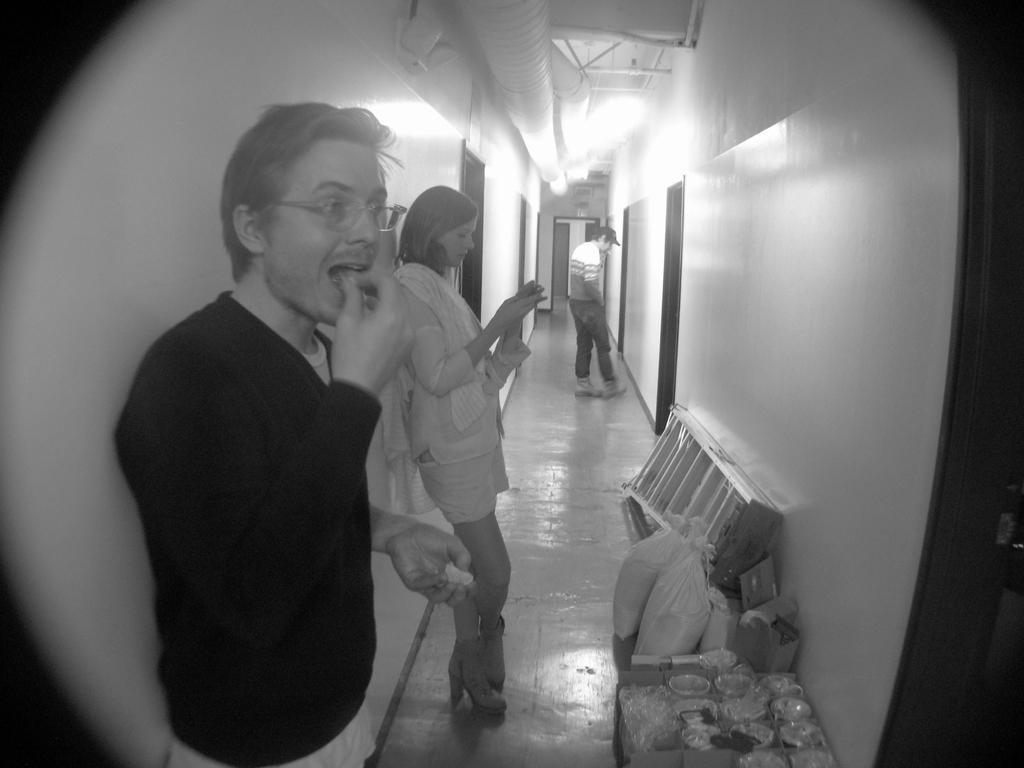In one or two sentences, can you explain what this image depicts? In this image there is a peephole of a door through which we can see there are three people standing in the corridor, there is a ladder and a few other objects on the floor. At the top of the image there is a ceiling with lights and some pipes, on the left and right side of the image there is a wall with doors. 